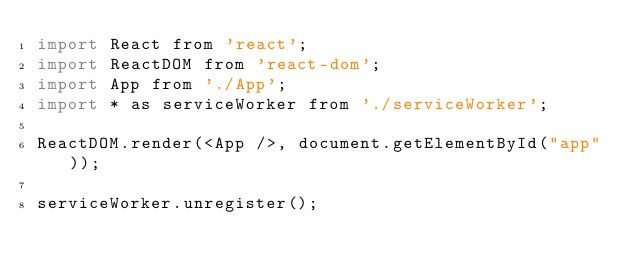<code> <loc_0><loc_0><loc_500><loc_500><_JavaScript_>import React from 'react';
import ReactDOM from 'react-dom';
import App from './App';
import * as serviceWorker from './serviceWorker';

ReactDOM.render(<App />, document.getElementById("app"));

serviceWorker.unregister();


</code> 